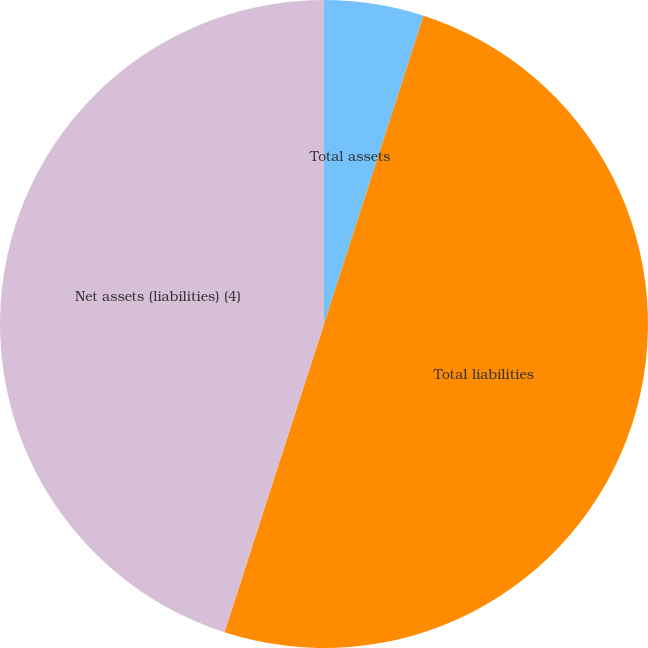Convert chart to OTSL. <chart><loc_0><loc_0><loc_500><loc_500><pie_chart><fcel>Total assets<fcel>Total liabilities<fcel>Net assets (liabilities) (4)<nl><fcel>4.97%<fcel>50.0%<fcel>45.03%<nl></chart> 